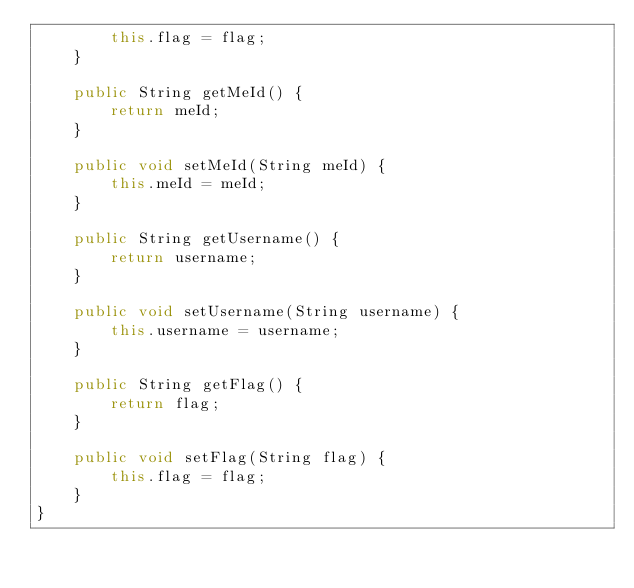Convert code to text. <code><loc_0><loc_0><loc_500><loc_500><_Java_>        this.flag = flag;
    }

    public String getMeId() {
        return meId;
    }

    public void setMeId(String meId) {
        this.meId = meId;
    }

    public String getUsername() {
        return username;
    }

    public void setUsername(String username) {
        this.username = username;
    }

    public String getFlag() {
        return flag;
    }

    public void setFlag(String flag) {
        this.flag = flag;
    }
}
</code> 